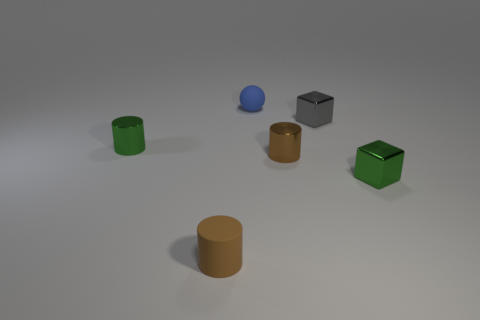How many brown cylinders must be subtracted to get 1 brown cylinders? 1 Add 2 small gray cylinders. How many objects exist? 8 Subtract all tiny brown cylinders. How many cylinders are left? 1 Subtract all green cylinders. How many cylinders are left? 2 Subtract all green spheres. How many green blocks are left? 1 Subtract all tiny green cylinders. Subtract all big gray shiny objects. How many objects are left? 5 Add 2 gray cubes. How many gray cubes are left? 3 Add 3 matte balls. How many matte balls exist? 4 Subtract 0 cyan cylinders. How many objects are left? 6 Subtract all blocks. How many objects are left? 4 